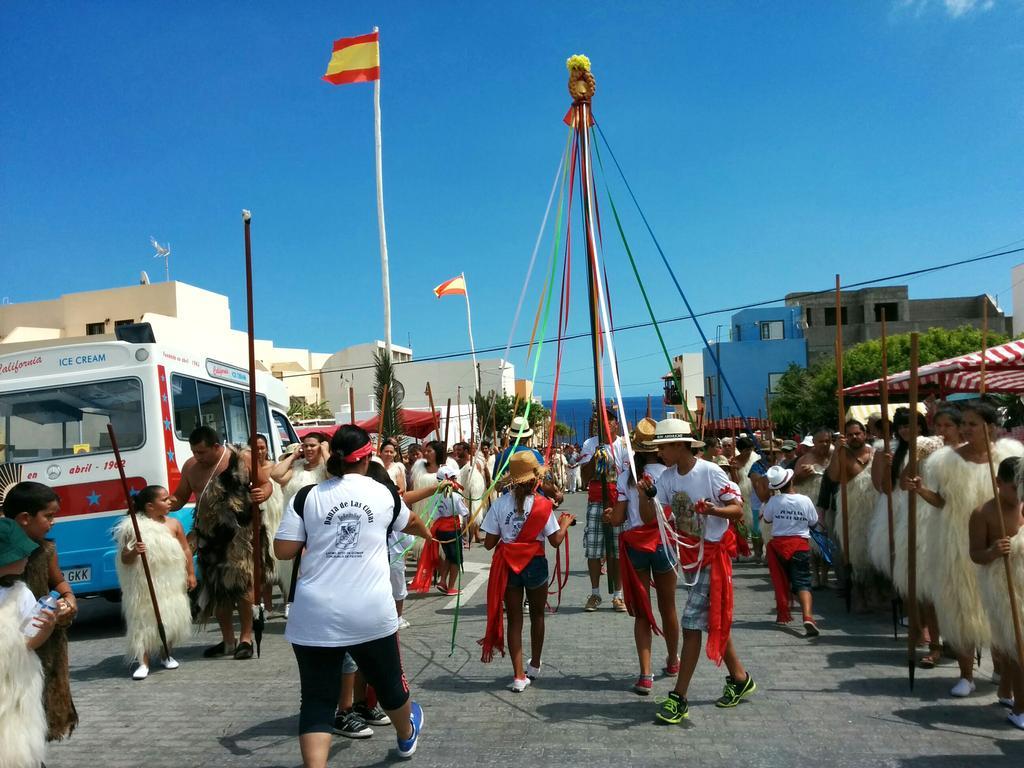Could you give a brief overview of what you see in this image? In this image we can see these people wearing white T-shirts are walking on the road by holding ropes, we can see these people are wearing different costumes are holding sticks, we can tent, a vehicle parked here, we can see trees, flags to the poles, buildings and the blue sky in the background. 